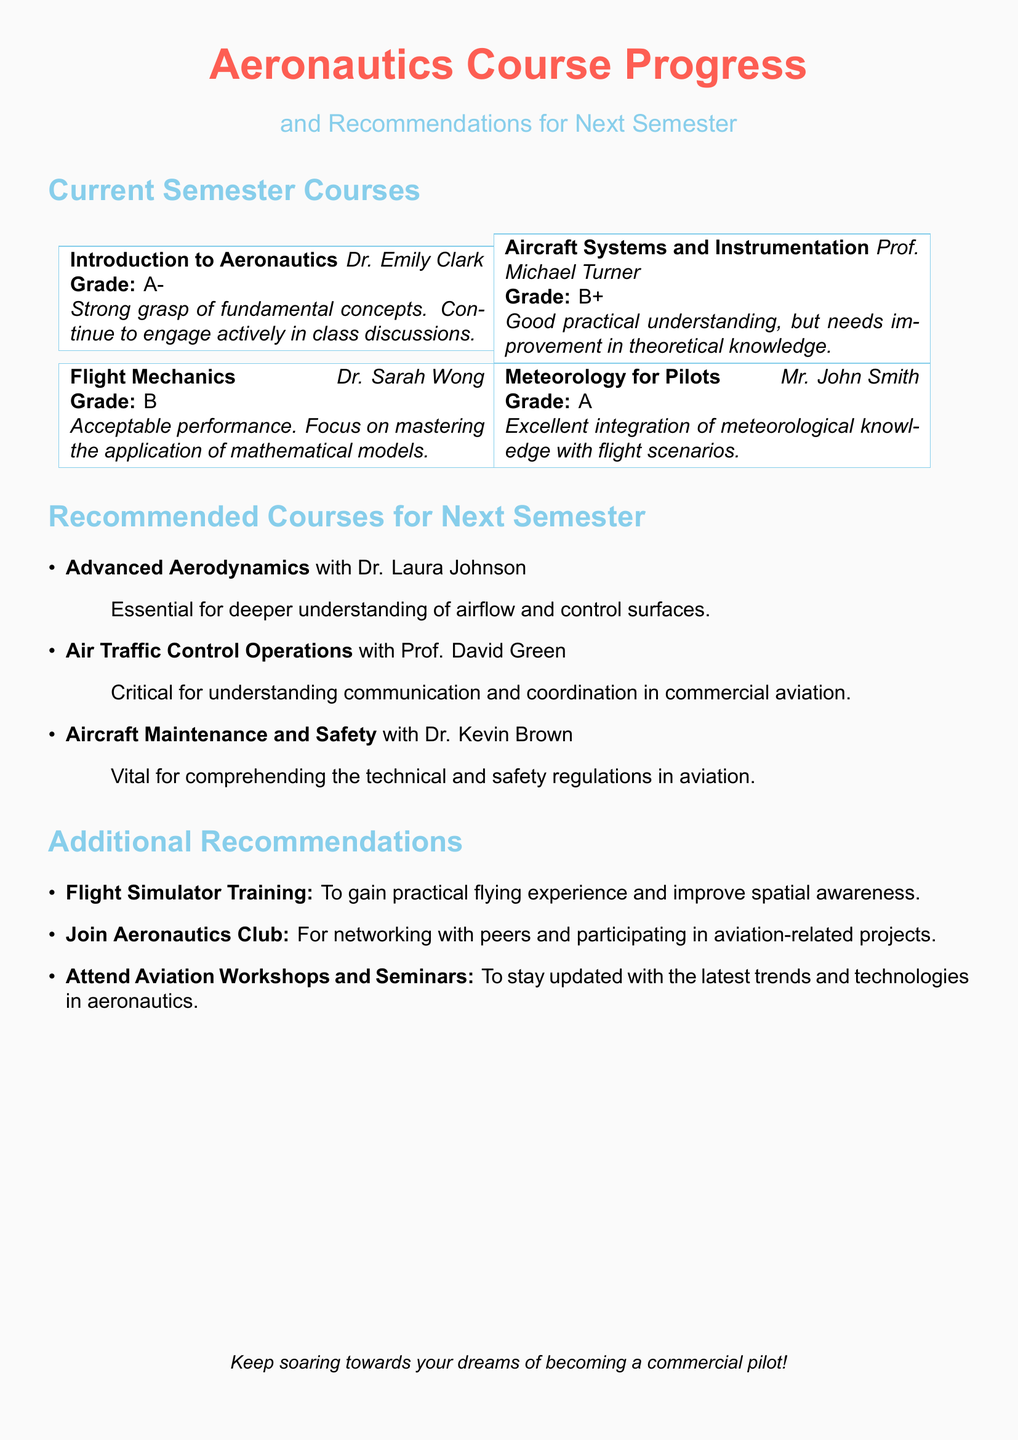What is the title of the document? The title is mentioned at the beginning of the document and signifies its purpose.
Answer: Aeronautics Course Progress and Recommendations for Next Semester Who teaches Aircraft Systems and Instrumentation? The instructor's name is provided in the course information in the document.
Answer: Prof. Michael Turner What grade did the student receive in Flight Mechanics? The grade is specified in the course section of the document.
Answer: B Which course is recommended for understanding airflow? The recommendation section provides specific courses and their significance.
Answer: Advanced Aerodynamics What is a suggested activity to improve practical flying experience? The additional recommendations section gives suggestions for gaining flying experience.
Answer: Flight Simulator Training How many courses are listed under Current Semester Courses? The document contains a section that enumerates the courses taken in the current semester.
Answer: Four What is the name of the instructor for the course Meteorology for Pilots? The instructor's name is mentioned alongside the course details in the document.
Answer: Mr. John Smith What is one benefit of joining the Aeronautics Club? The document outlines additional recommendations, including benefits of joining clubs.
Answer: Networking with peers What topic does the course Air Traffic Control Operations focus on? The focus of the course is clarified in the recommendation section.
Answer: Communication and coordination in commercial aviation 